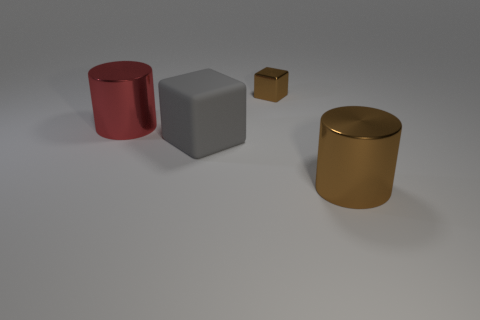The large shiny object that is the same color as the tiny block is what shape?
Provide a succinct answer. Cylinder. What is the size of the cylinder to the left of the brown shiny object that is in front of the red thing?
Ensure brevity in your answer.  Large. Is the color of the large rubber cube the same as the large metallic thing that is in front of the gray matte object?
Make the answer very short. No. Is the number of tiny brown blocks that are behind the large rubber block less than the number of objects?
Offer a very short reply. Yes. What number of other things are the same size as the matte object?
Make the answer very short. 2. There is a brown object to the right of the small object; does it have the same shape as the large matte object?
Keep it short and to the point. No. Is the number of small objects on the left side of the small thing greater than the number of small yellow shiny things?
Ensure brevity in your answer.  No. There is a object that is right of the red metallic cylinder and behind the big gray cube; what is its material?
Your answer should be compact. Metal. Is there any other thing that has the same shape as the large gray object?
Provide a short and direct response. Yes. How many shiny things are both behind the gray rubber object and right of the red object?
Your answer should be compact. 1. 